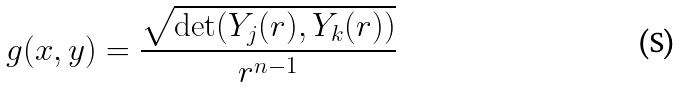Convert formula to latex. <formula><loc_0><loc_0><loc_500><loc_500>g ( x , y ) = \frac { \sqrt { \det ( Y _ { j } ( r ) , Y _ { k } ( r ) ) } } { r ^ { n - 1 } }</formula> 